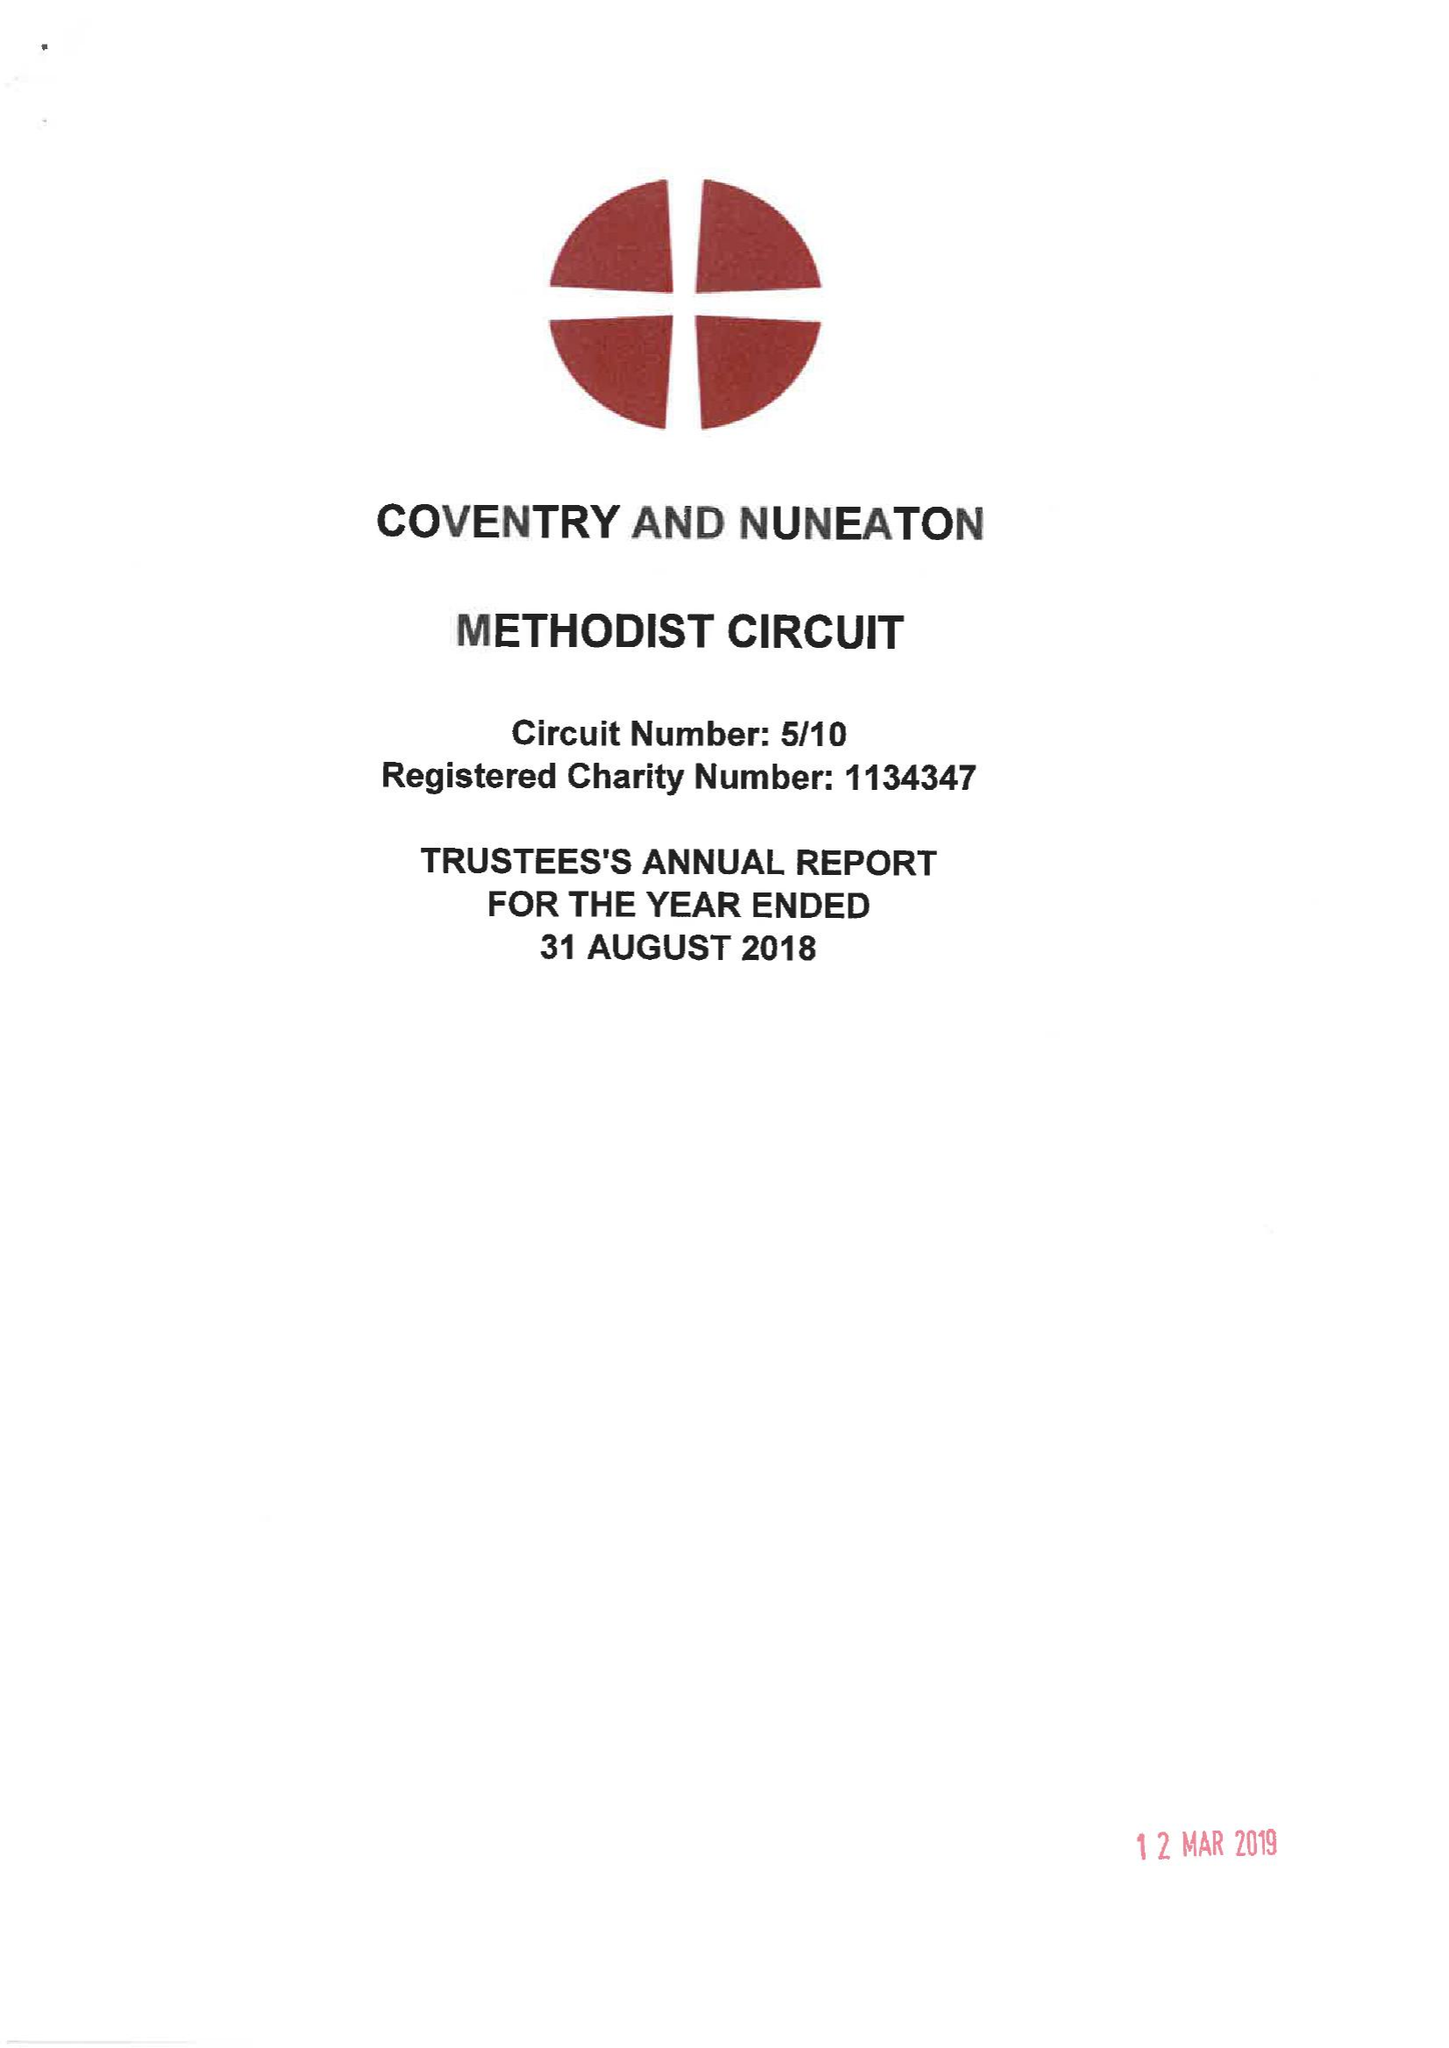What is the value for the report_date?
Answer the question using a single word or phrase. 2018-08-31 